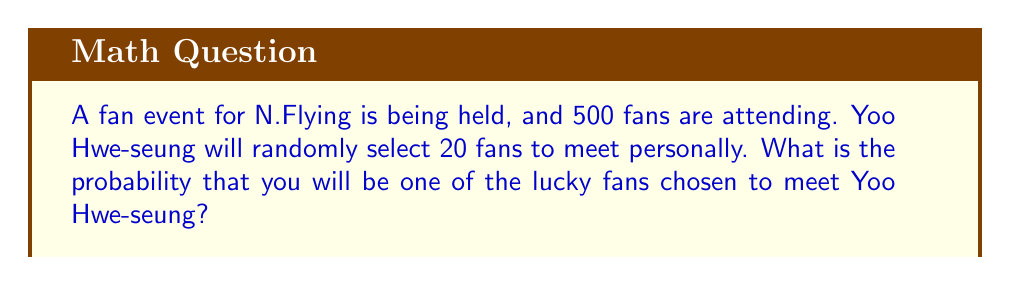Show me your answer to this math problem. Let's approach this step-by-step:

1) This is a classic probability problem where we need to calculate the number of favorable outcomes divided by the total number of possible outcomes.

2) The total number of possible outcomes is the number of ways to choose 20 fans from 500. This can be represented by the combination formula:

   $$\binom{500}{20} = \frac{500!}{20!(500-20)!} = \frac{500!}{20!480!}$$

3) The number of favorable outcomes is the number of ways to choose you (which is always 1) multiplied by the number of ways to choose the remaining 19 fans from the other 499:

   $$1 \cdot \binom{499}{19} = \frac{499!}{19!480!}$$

4) The probability is then:

   $$P(\text{being chosen}) = \frac{\text{favorable outcomes}}{\text{total outcomes}} = \frac{1 \cdot \binom{499}{19}}{\binom{500}{20}}$$

5) Simplifying:

   $$P(\text{being chosen}) = \frac{\frac{499!}{19!480!}}{\frac{500!}{20!480!}} = \frac{499! \cdot 20!}{500! \cdot 19!} = \frac{20}{500} = \frac{1}{25} = 0.04$$

Therefore, the probability of being chosen to meet Yoo Hwe-seung is 0.04 or 4%.
Answer: $\frac{1}{25}$ or 0.04 or 4% 